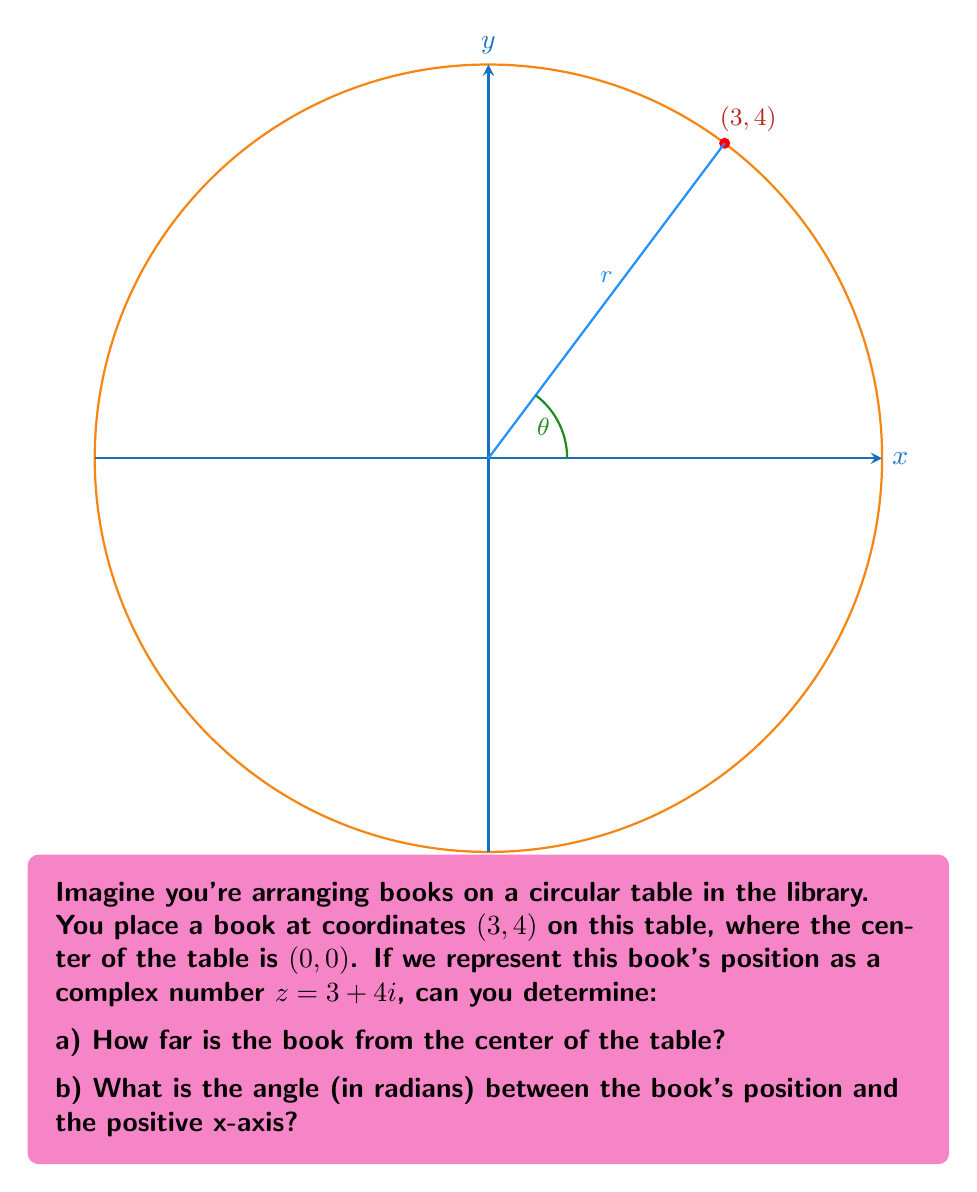Can you answer this question? Let's approach this step-by-step:

1) For a complex number $z = a + bi$, its magnitude (or absolute value) is given by:

   $|z| = \sqrt{a^2 + b^2}$

   This represents the distance from the origin to the point (a,b) in the complex plane.

2) The argument of a complex number is the angle between the positive real axis and the line from the origin to the point (a,b). It's calculated using the arctangent function:

   $\arg(z) = \tan^{-1}(\frac{b}{a})$

   Note: We need to be careful about which quadrant the point is in, as arctangent only gives values between $-\frac{\pi}{2}$ and $\frac{\pi}{2}$.

3) In our case, $z = 3 + 4i$, so $a = 3$ and $b = 4$.

4) To find the magnitude:
   
   $|z| = \sqrt{3^2 + 4^2} = \sqrt{9 + 16} = \sqrt{25} = 5$

5) To find the argument:
   
   $\arg(z) = \tan^{-1}(\frac{4}{3}) \approx 0.9273$ radians

   Since both a and b are positive, our point is in the first quadrant, so this result is correct as is.

Therefore, the book is 5 units away from the center of the table, and it's positioned at an angle of approximately 0.9273 radians (or about 53.13 degrees) from the positive x-axis.
Answer: a) 5
b) $\tan^{-1}(\frac{4}{3}) \approx 0.9273$ radians 